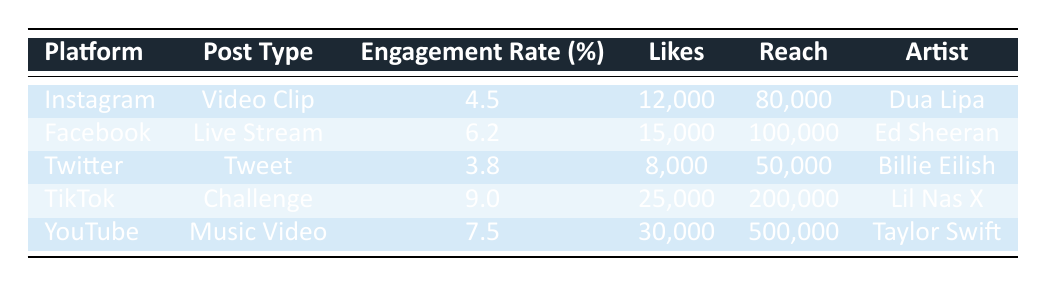What is the engagement rate for TikTok posts? Referring to the table, the engagement rate for TikTok is directly stated. It shows 9.0% for the challenge post by Lil Nas X.
Answer: 9.0% Which artist had the highest number of likes and how many did they receive? By inspecting the likes column, Taylor Swift received the highest number with 30,000 likes as per the information listed in the table.
Answer: 30,000 True or False: The engagement rate for Facebook posts is higher than that of Twitter posts. Looking at the engagement rates, Facebook has a 6.2% engagement rate while Twitter has a 3.8% engagement rate. Since 6.2% is greater than 3.8%, the statement is true.
Answer: True What is the difference in the number of shares between the highest and lowest post types? The highest number of shares is from TikTok with 3,500 shares and the lowest is YouTube with 700 shares. To find the difference: 3500 - 700 = 2800.
Answer: 2800 Which social media platform had the least reach and what was the reach value? By examining the reach column, Twitter has the least reach with a value of 50,000.
Answer: 50,000 What is the average engagement rate across all platforms? The engagement rates for the platforms are: 4.5, 6.2, 3.8, 9.0, and 7.5. Adding these gives: 4.5 + 6.2 + 3.8 + 9.0 + 7.5 = 31.0. There are 5 posts, so the average is 31.0 / 5 = 6.2%.
Answer: 6.2% Which platform featured a live stream post by Ed Sheeran? The table shows that Facebook was the platform where Ed Sheeran conducted a live stream post.
Answer: Facebook What is the total number of likes for all posts combined? The total likes can be calculated by summing the likes from each platform: 12,000 + 15,000 + 8,000 + 25,000 + 30,000 = 90,000. Thus, the total likes for all posts combined is 90,000.
Answer: 90,000 